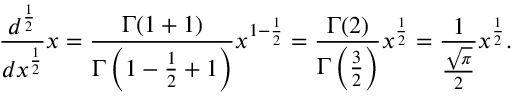Convert formula to latex. <formula><loc_0><loc_0><loc_500><loc_500>{ \frac { d ^ { \frac { 1 } { 2 } } } { d x ^ { \frac { 1 } { 2 } } } } x = { \frac { \Gamma ( 1 + 1 ) } { \Gamma \left ( 1 - { \frac { 1 } { 2 } } + 1 \right ) } } x ^ { 1 - { \frac { 1 } { 2 } } } = { \frac { \Gamma ( 2 ) } { \Gamma \left ( { \frac { 3 } { 2 } } \right ) } } x ^ { \frac { 1 } { 2 } } = { \frac { 1 } { \frac { \sqrt { \pi } } { 2 } } } x ^ { \frac { 1 } { 2 } } .</formula> 